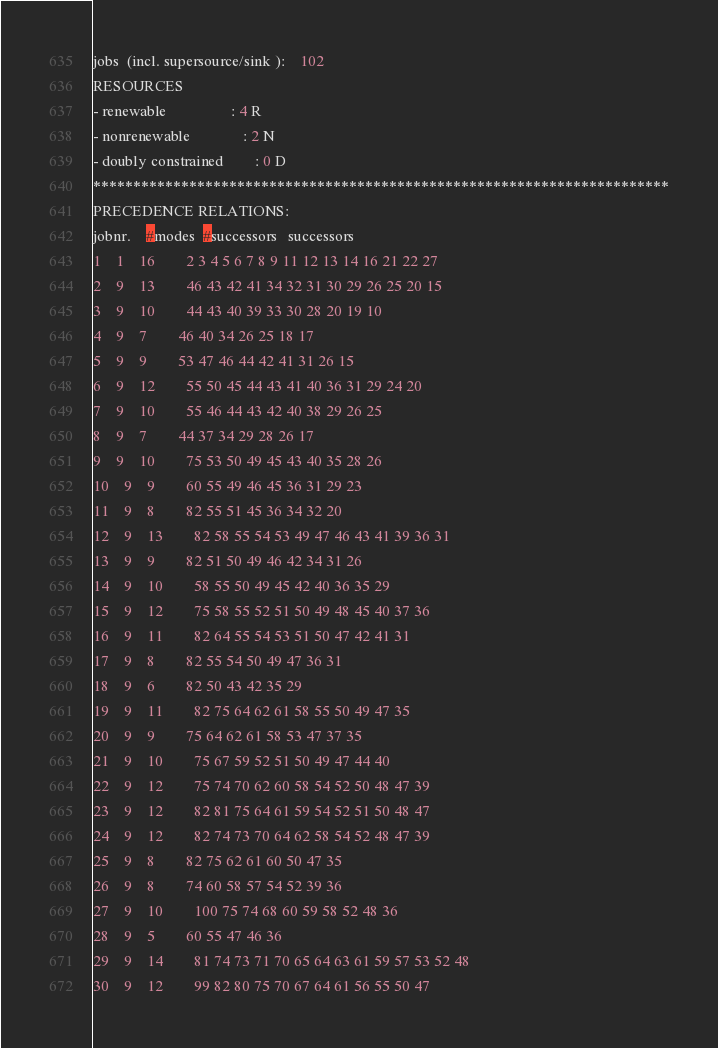<code> <loc_0><loc_0><loc_500><loc_500><_ObjectiveC_>jobs  (incl. supersource/sink ):	102
RESOURCES
- renewable                 : 4 R
- nonrenewable              : 2 N
- doubly constrained        : 0 D
************************************************************************
PRECEDENCE RELATIONS:
jobnr.    #modes  #successors   successors
1	1	16		2 3 4 5 6 7 8 9 11 12 13 14 16 21 22 27 
2	9	13		46 43 42 41 34 32 31 30 29 26 25 20 15 
3	9	10		44 43 40 39 33 30 28 20 19 10 
4	9	7		46 40 34 26 25 18 17 
5	9	9		53 47 46 44 42 41 31 26 15 
6	9	12		55 50 45 44 43 41 40 36 31 29 24 20 
7	9	10		55 46 44 43 42 40 38 29 26 25 
8	9	7		44 37 34 29 28 26 17 
9	9	10		75 53 50 49 45 43 40 35 28 26 
10	9	9		60 55 49 46 45 36 31 29 23 
11	9	8		82 55 51 45 36 34 32 20 
12	9	13		82 58 55 54 53 49 47 46 43 41 39 36 31 
13	9	9		82 51 50 49 46 42 34 31 26 
14	9	10		58 55 50 49 45 42 40 36 35 29 
15	9	12		75 58 55 52 51 50 49 48 45 40 37 36 
16	9	11		82 64 55 54 53 51 50 47 42 41 31 
17	9	8		82 55 54 50 49 47 36 31 
18	9	6		82 50 43 42 35 29 
19	9	11		82 75 64 62 61 58 55 50 49 47 35 
20	9	9		75 64 62 61 58 53 47 37 35 
21	9	10		75 67 59 52 51 50 49 47 44 40 
22	9	12		75 74 70 62 60 58 54 52 50 48 47 39 
23	9	12		82 81 75 64 61 59 54 52 51 50 48 47 
24	9	12		82 74 73 70 64 62 58 54 52 48 47 39 
25	9	8		82 75 62 61 60 50 47 35 
26	9	8		74 60 58 57 54 52 39 36 
27	9	10		100 75 74 68 60 59 58 52 48 36 
28	9	5		60 55 47 46 36 
29	9	14		81 74 73 71 70 65 64 63 61 59 57 53 52 48 
30	9	12		99 82 80 75 70 67 64 61 56 55 50 47 </code> 